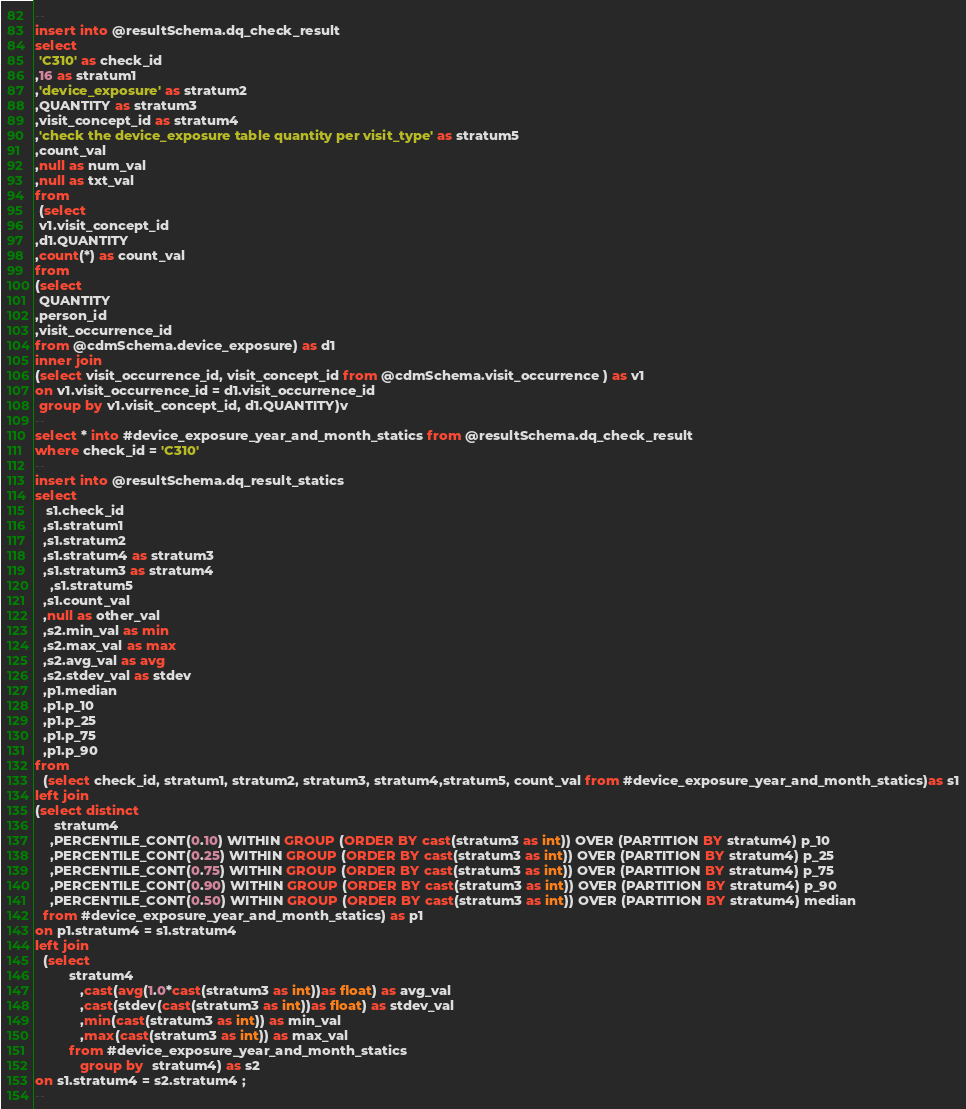<code> <loc_0><loc_0><loc_500><loc_500><_SQL_>--
insert into @resultSchema.dq_check_result
select
 'C310' as check_id
,16 as stratum1
,'device_exposure' as stratum2
,QUANTITY as stratum3
,visit_concept_id as stratum4
,'check the device_exposure table quantity per visit_type' as stratum5
,count_val
,null as num_val
,null as txt_val
from
 (select
 v1.visit_concept_id
,d1.QUANTITY
,count(*) as count_val
from
(select
 QUANTITY
,person_id
,visit_occurrence_id
from @cdmSchema.device_exposure) as d1
inner join
(select visit_occurrence_id, visit_concept_id from @cdmSchema.visit_occurrence ) as v1
on v1.visit_occurrence_id = d1.visit_occurrence_id
 group by v1.visit_concept_id, d1.QUANTITY)v
--
select * into #device_exposure_year_and_month_statics from @resultSchema.dq_check_result
where check_id = 'C310'
--
insert into @resultSchema.dq_result_statics
select
   s1.check_id
  ,s1.stratum1
  ,s1.stratum2
  ,s1.stratum4 as stratum3
  ,s1.stratum3 as stratum4
	,s1.stratum5
  ,s1.count_val
  ,null as other_val
  ,s2.min_val as min
  ,s2.max_val as max
  ,s2.avg_val as avg
  ,s2.stdev_val as stdev
  ,p1.median
  ,p1.p_10
  ,p1.p_25
  ,p1.p_75
  ,p1.p_90
from
  (select check_id, stratum1, stratum2, stratum3, stratum4,stratum5, count_val from #device_exposure_year_and_month_statics)as s1
left join
(select distinct
	 stratum4
	,PERCENTILE_CONT(0.10) WITHIN GROUP (ORDER BY cast(stratum3 as int)) OVER (PARTITION BY stratum4) p_10
	,PERCENTILE_CONT(0.25) WITHIN GROUP (ORDER BY cast(stratum3 as int)) OVER (PARTITION BY stratum4) p_25
	,PERCENTILE_CONT(0.75) WITHIN GROUP (ORDER BY cast(stratum3 as int)) OVER (PARTITION BY stratum4) p_75
	,PERCENTILE_CONT(0.90) WITHIN GROUP (ORDER BY cast(stratum3 as int)) OVER (PARTITION BY stratum4) p_90
	,PERCENTILE_CONT(0.50) WITHIN GROUP (ORDER BY cast(stratum3 as int)) OVER (PARTITION BY stratum4) median
  from #device_exposure_year_and_month_statics) as p1
on p1.stratum4 = s1.stratum4
left join
  (select
  		 stratum4
 			,cast(avg(1.0*cast(stratum3 as int))as float) as avg_val
			,cast(stdev(cast(stratum3 as int))as float) as stdev_val
			,min(cast(stratum3 as int)) as min_val
			,max(cast(stratum3 as int)) as max_val
		 from #device_exposure_year_and_month_statics
			group by  stratum4) as s2
on s1.stratum4 = s2.stratum4 ;
--</code> 